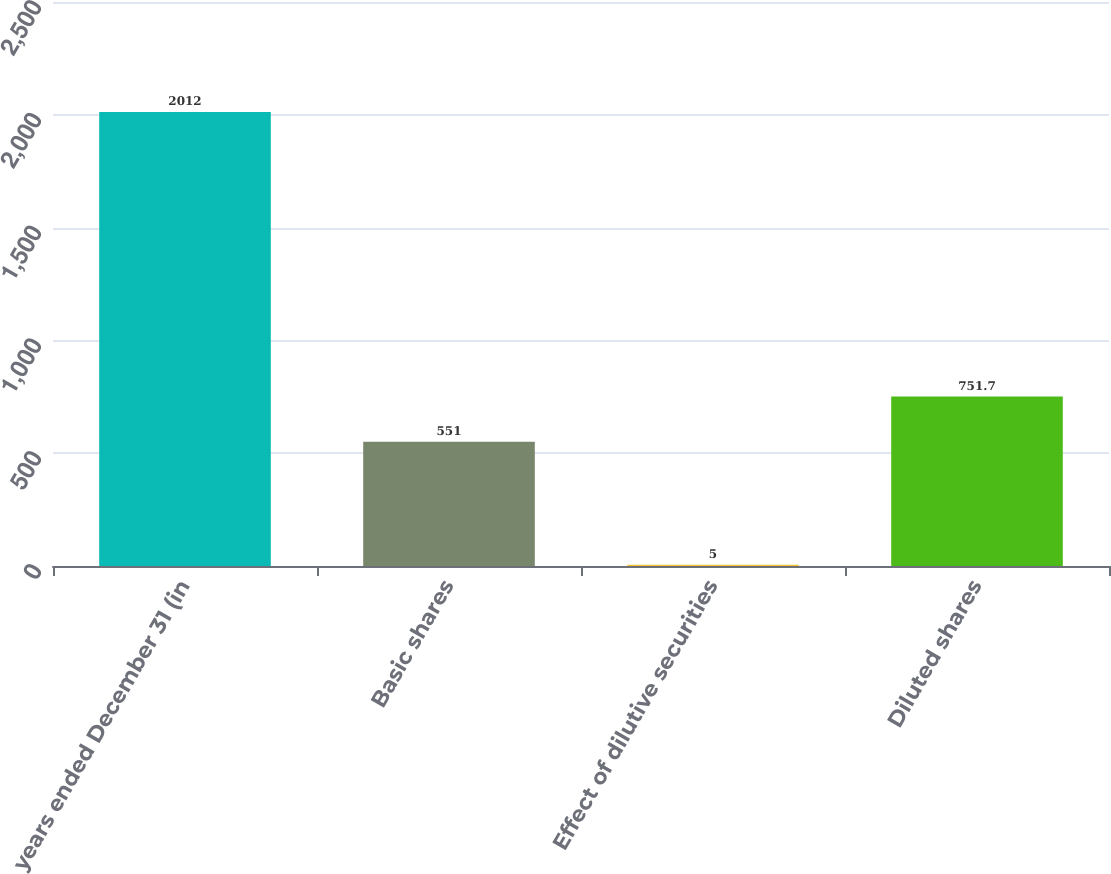Convert chart to OTSL. <chart><loc_0><loc_0><loc_500><loc_500><bar_chart><fcel>years ended December 31 (in<fcel>Basic shares<fcel>Effect of dilutive securities<fcel>Diluted shares<nl><fcel>2012<fcel>551<fcel>5<fcel>751.7<nl></chart> 